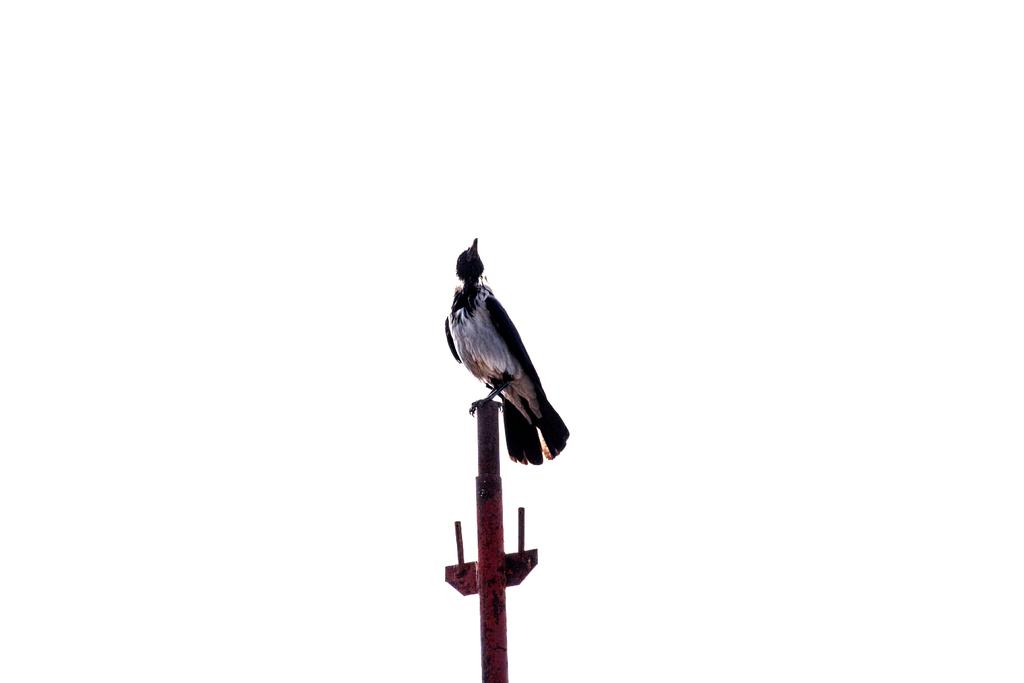What animal is present in the image? There is a crow in the picture. What is the color of the crow? The crow is black in color. Where is the crow sitting in the image? The crow is sitting on an iron pole. What is the color of the background in the image? The background of the image is white. How many hens are visible in the image? There are no hens present in the image; it features a crow sitting on an iron pole. What type of beggar can be seen in the image? There is no beggar present in the image. 